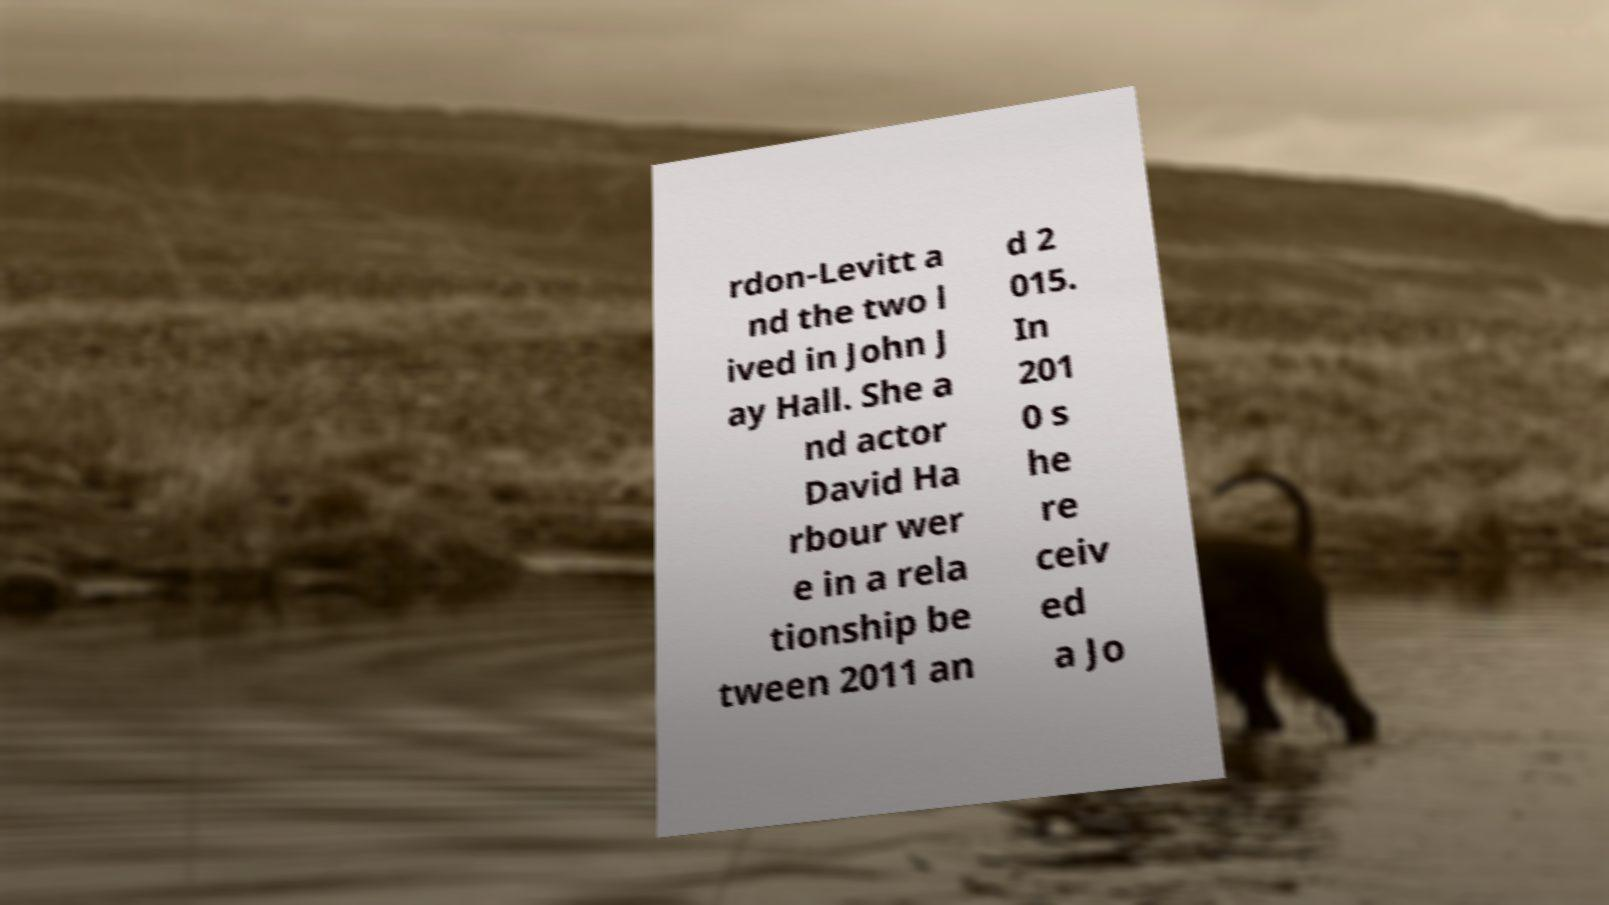What messages or text are displayed in this image? I need them in a readable, typed format. rdon-Levitt a nd the two l ived in John J ay Hall. She a nd actor David Ha rbour wer e in a rela tionship be tween 2011 an d 2 015. In 201 0 s he re ceiv ed a Jo 